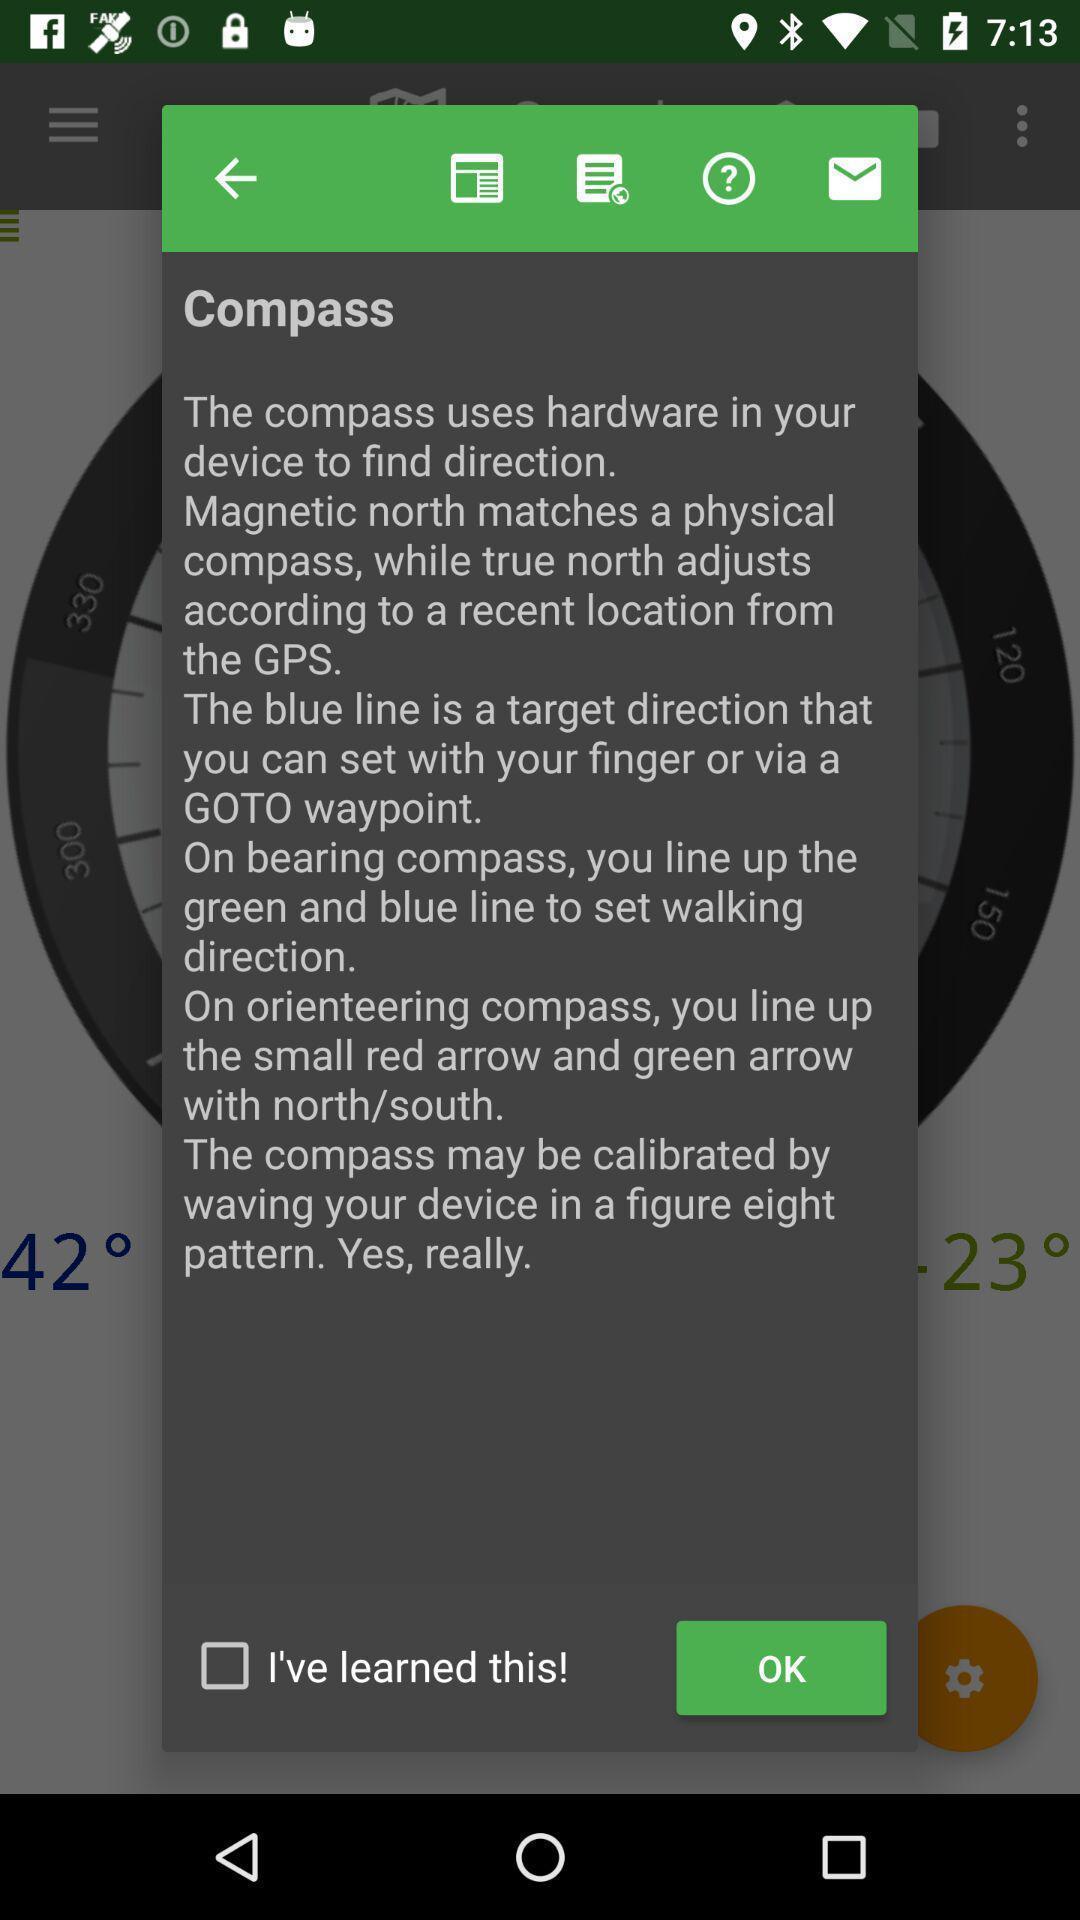Give me a summary of this screen capture. Pop-up for confirmation of compass to find direction. 